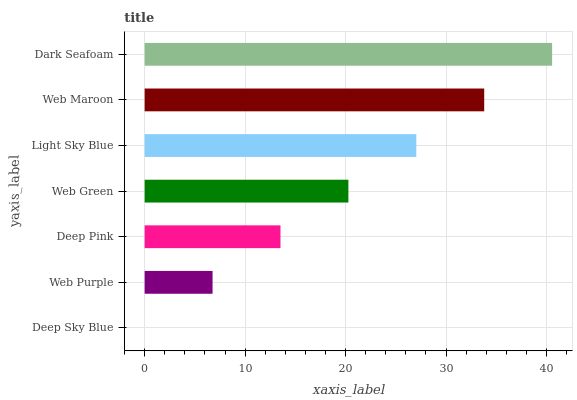Is Deep Sky Blue the minimum?
Answer yes or no. Yes. Is Dark Seafoam the maximum?
Answer yes or no. Yes. Is Web Purple the minimum?
Answer yes or no. No. Is Web Purple the maximum?
Answer yes or no. No. Is Web Purple greater than Deep Sky Blue?
Answer yes or no. Yes. Is Deep Sky Blue less than Web Purple?
Answer yes or no. Yes. Is Deep Sky Blue greater than Web Purple?
Answer yes or no. No. Is Web Purple less than Deep Sky Blue?
Answer yes or no. No. Is Web Green the high median?
Answer yes or no. Yes. Is Web Green the low median?
Answer yes or no. Yes. Is Dark Seafoam the high median?
Answer yes or no. No. Is Deep Pink the low median?
Answer yes or no. No. 